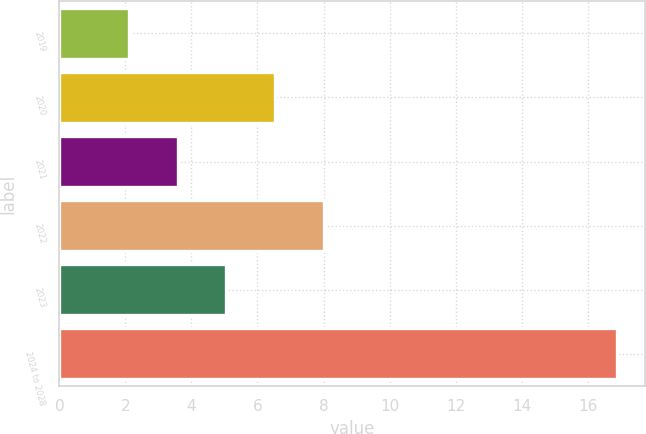Convert chart. <chart><loc_0><loc_0><loc_500><loc_500><bar_chart><fcel>2019<fcel>2020<fcel>2021<fcel>2022<fcel>2023<fcel>2024 to 2028<nl><fcel>2.1<fcel>6.54<fcel>3.58<fcel>8.02<fcel>5.06<fcel>16.9<nl></chart> 